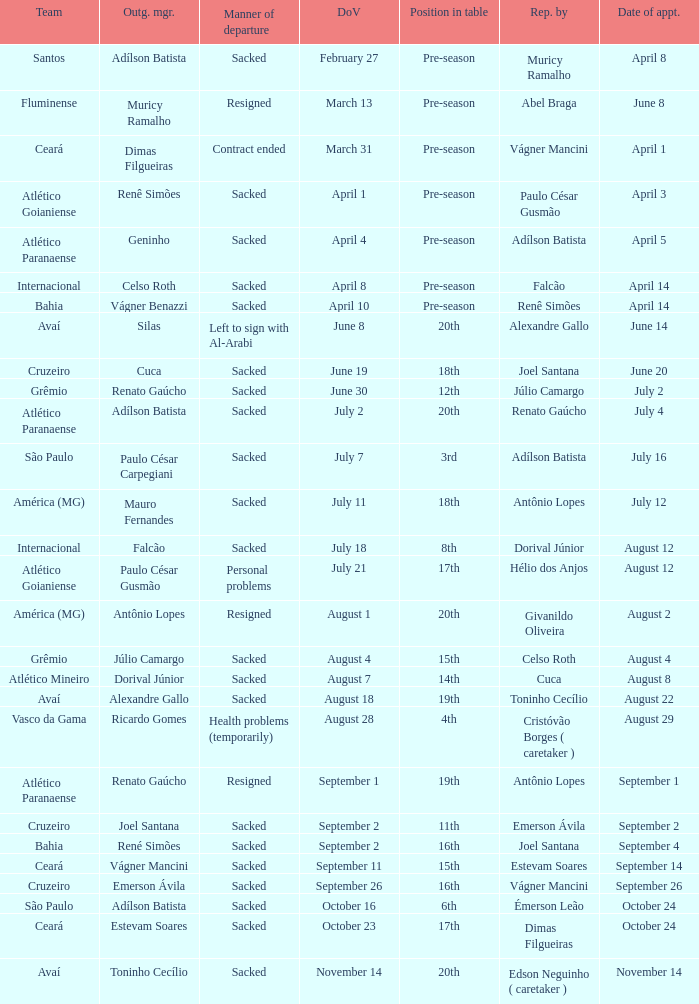Would you be able to parse every entry in this table? {'header': ['Team', 'Outg. mgr.', 'Manner of departure', 'DoV', 'Position in table', 'Rep. by', 'Date of appt.'], 'rows': [['Santos', 'Adílson Batista', 'Sacked', 'February 27', 'Pre-season', 'Muricy Ramalho', 'April 8'], ['Fluminense', 'Muricy Ramalho', 'Resigned', 'March 13', 'Pre-season', 'Abel Braga', 'June 8'], ['Ceará', 'Dimas Filgueiras', 'Contract ended', 'March 31', 'Pre-season', 'Vágner Mancini', 'April 1'], ['Atlético Goianiense', 'Renê Simões', 'Sacked', 'April 1', 'Pre-season', 'Paulo César Gusmão', 'April 3'], ['Atlético Paranaense', 'Geninho', 'Sacked', 'April 4', 'Pre-season', 'Adílson Batista', 'April 5'], ['Internacional', 'Celso Roth', 'Sacked', 'April 8', 'Pre-season', 'Falcão', 'April 14'], ['Bahia', 'Vágner Benazzi', 'Sacked', 'April 10', 'Pre-season', 'Renê Simões', 'April 14'], ['Avaí', 'Silas', 'Left to sign with Al-Arabi', 'June 8', '20th', 'Alexandre Gallo', 'June 14'], ['Cruzeiro', 'Cuca', 'Sacked', 'June 19', '18th', 'Joel Santana', 'June 20'], ['Grêmio', 'Renato Gaúcho', 'Sacked', 'June 30', '12th', 'Júlio Camargo', 'July 2'], ['Atlético Paranaense', 'Adílson Batista', 'Sacked', 'July 2', '20th', 'Renato Gaúcho', 'July 4'], ['São Paulo', 'Paulo César Carpegiani', 'Sacked', 'July 7', '3rd', 'Adílson Batista', 'July 16'], ['América (MG)', 'Mauro Fernandes', 'Sacked', 'July 11', '18th', 'Antônio Lopes', 'July 12'], ['Internacional', 'Falcão', 'Sacked', 'July 18', '8th', 'Dorival Júnior', 'August 12'], ['Atlético Goianiense', 'Paulo César Gusmão', 'Personal problems', 'July 21', '17th', 'Hélio dos Anjos', 'August 12'], ['América (MG)', 'Antônio Lopes', 'Resigned', 'August 1', '20th', 'Givanildo Oliveira', 'August 2'], ['Grêmio', 'Júlio Camargo', 'Sacked', 'August 4', '15th', 'Celso Roth', 'August 4'], ['Atlético Mineiro', 'Dorival Júnior', 'Sacked', 'August 7', '14th', 'Cuca', 'August 8'], ['Avaí', 'Alexandre Gallo', 'Sacked', 'August 18', '19th', 'Toninho Cecílio', 'August 22'], ['Vasco da Gama', 'Ricardo Gomes', 'Health problems (temporarily)', 'August 28', '4th', 'Cristóvão Borges ( caretaker )', 'August 29'], ['Atlético Paranaense', 'Renato Gaúcho', 'Resigned', 'September 1', '19th', 'Antônio Lopes', 'September 1'], ['Cruzeiro', 'Joel Santana', 'Sacked', 'September 2', '11th', 'Emerson Ávila', 'September 2'], ['Bahia', 'René Simões', 'Sacked', 'September 2', '16th', 'Joel Santana', 'September 4'], ['Ceará', 'Vágner Mancini', 'Sacked', 'September 11', '15th', 'Estevam Soares', 'September 14'], ['Cruzeiro', 'Emerson Ávila', 'Sacked', 'September 26', '16th', 'Vágner Mancini', 'September 26'], ['São Paulo', 'Adílson Batista', 'Sacked', 'October 16', '6th', 'Émerson Leão', 'October 24'], ['Ceará', 'Estevam Soares', 'Sacked', 'October 23', '17th', 'Dimas Filgueiras', 'October 24'], ['Avaí', 'Toninho Cecílio', 'Sacked', 'November 14', '20th', 'Edson Neguinho ( caretaker )', 'November 14']]} What team hired Renato Gaúcho? Atlético Paranaense. 